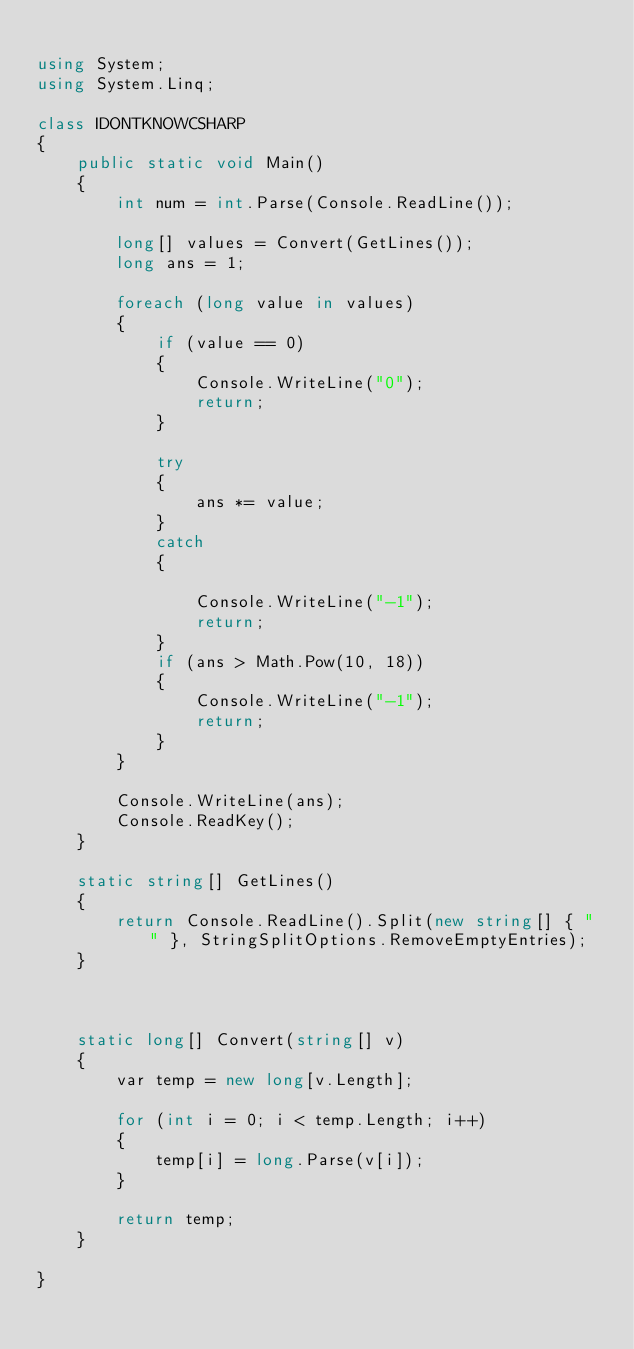<code> <loc_0><loc_0><loc_500><loc_500><_C#_>
using System;
using System.Linq;

class IDONTKNOWCSHARP
{
    public static void Main()
    {
        int num = int.Parse(Console.ReadLine());

        long[] values = Convert(GetLines());
        long ans = 1;

        foreach (long value in values)
        {
            if (value == 0)
            {
                Console.WriteLine("0");
                return;
            }

            try
            {
                ans *= value;
            }
            catch
            {

                Console.WriteLine("-1");
                return;
            }
            if (ans > Math.Pow(10, 18))
            {
                Console.WriteLine("-1");
                return;
            }
        }

        Console.WriteLine(ans);
        Console.ReadKey();
    }

    static string[] GetLines()
    {
        return Console.ReadLine().Split(new string[] { " " }, StringSplitOptions.RemoveEmptyEntries);
    }



    static long[] Convert(string[] v)
    {
        var temp = new long[v.Length];

        for (int i = 0; i < temp.Length; i++)
        {
            temp[i] = long.Parse(v[i]);
        }

        return temp;
    }

}</code> 